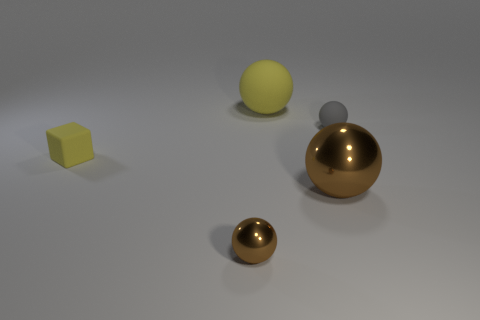Could you infer the relative sizes of these objects? Based on their appearance relative to each other, the larger gold sphere in the middle of the image is the biggest object, followed by the yellow rubber cube and the yellow sphere. The small gray sphere on top of the yellow one is the next in size, and the tiny brown ball is the smallest object among them. 